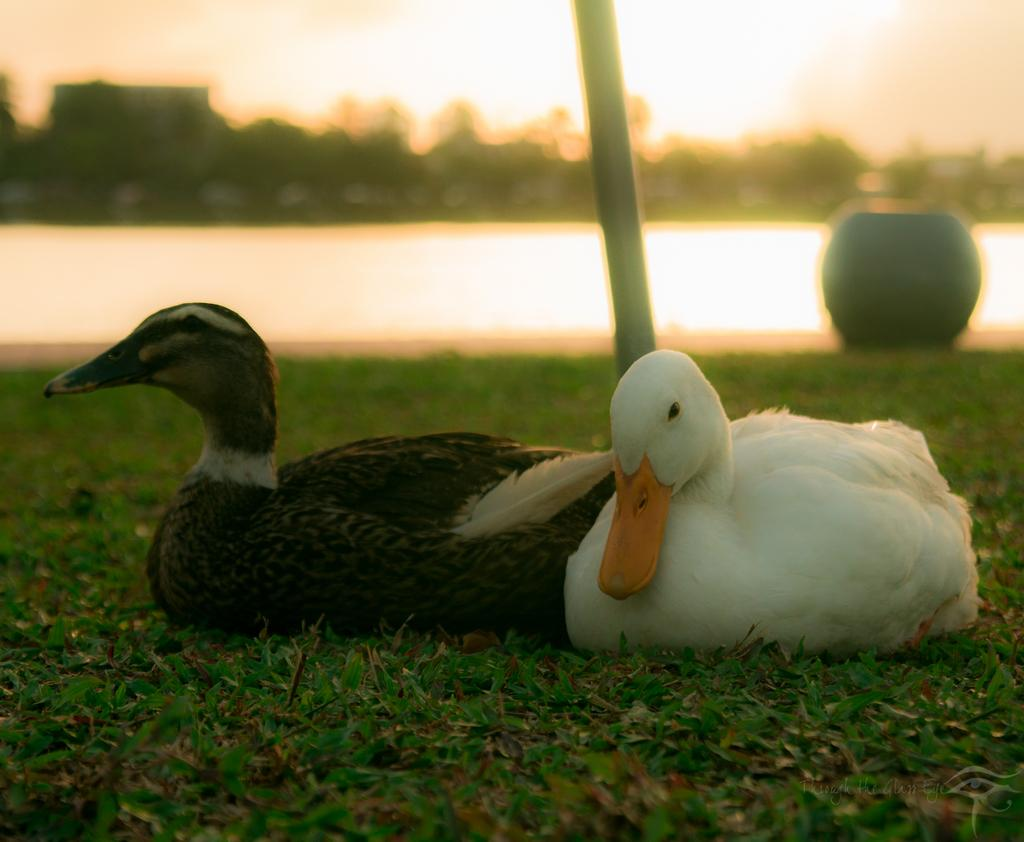How many ducks are present in the image? There are two ducks in the image. What colors are the ducks? The ducks are black and white in color. Where are the ducks located in the image? The ducks are sitting in the grass lawn. What can be seen in the background of the image? There is water visible in the background of the image. How is the background of the image depicted? The background of the image is blurred. What does the duck's brother wish for in the image? There is no mention of a brother or a wish in the image; it only features two ducks sitting in the grass lawn. What is the duck using to collect water in the image? There is no bucket or any indication of water collection in the image. 